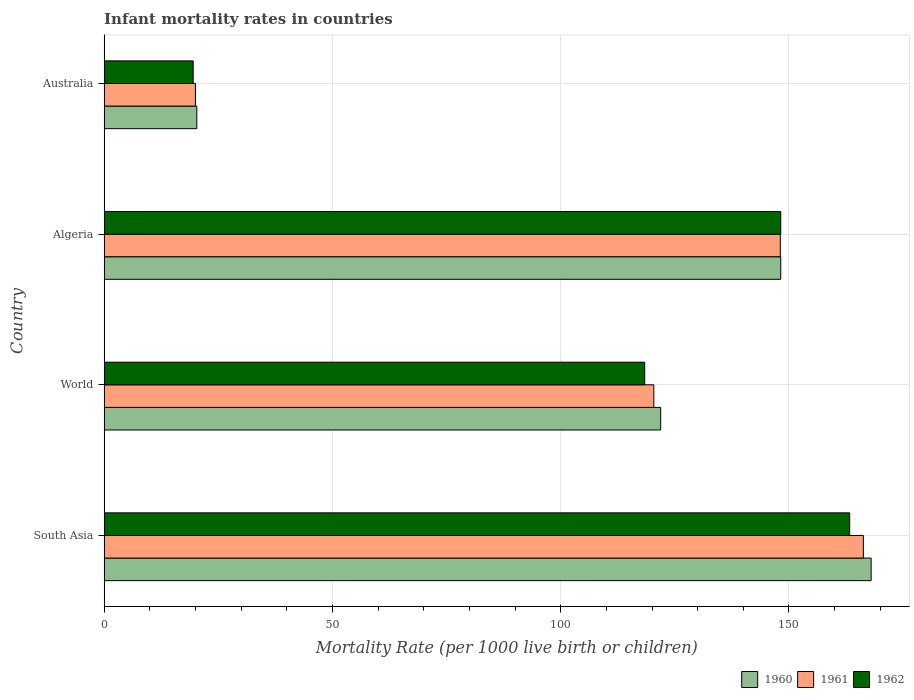How many groups of bars are there?
Your answer should be very brief. 4. Are the number of bars per tick equal to the number of legend labels?
Provide a short and direct response. Yes. How many bars are there on the 3rd tick from the bottom?
Make the answer very short. 3. What is the label of the 3rd group of bars from the top?
Give a very brief answer. World. In how many cases, is the number of bars for a given country not equal to the number of legend labels?
Give a very brief answer. 0. What is the infant mortality rate in 1961 in South Asia?
Your answer should be compact. 166.3. Across all countries, what is the maximum infant mortality rate in 1961?
Provide a short and direct response. 166.3. Across all countries, what is the minimum infant mortality rate in 1960?
Your response must be concise. 20.3. What is the total infant mortality rate in 1962 in the graph?
Your answer should be compact. 449.4. What is the difference between the infant mortality rate in 1961 in Algeria and that in Australia?
Provide a short and direct response. 128.1. What is the difference between the infant mortality rate in 1962 in South Asia and the infant mortality rate in 1960 in World?
Offer a terse response. 41.4. What is the average infant mortality rate in 1962 per country?
Give a very brief answer. 112.35. What is the difference between the infant mortality rate in 1961 and infant mortality rate in 1962 in South Asia?
Provide a short and direct response. 3. In how many countries, is the infant mortality rate in 1962 greater than 30 ?
Provide a succinct answer. 3. What is the ratio of the infant mortality rate in 1961 in Algeria to that in Australia?
Offer a very short reply. 7.4. Is the infant mortality rate in 1962 in Australia less than that in South Asia?
Ensure brevity in your answer.  Yes. What is the difference between the highest and the second highest infant mortality rate in 1962?
Keep it short and to the point. 15.1. What is the difference between the highest and the lowest infant mortality rate in 1961?
Offer a very short reply. 146.3. In how many countries, is the infant mortality rate in 1960 greater than the average infant mortality rate in 1960 taken over all countries?
Offer a terse response. 3. Is the sum of the infant mortality rate in 1962 in Algeria and World greater than the maximum infant mortality rate in 1961 across all countries?
Make the answer very short. Yes. What does the 1st bar from the top in Australia represents?
Offer a terse response. 1962. What does the 2nd bar from the bottom in Australia represents?
Your response must be concise. 1961. Is it the case that in every country, the sum of the infant mortality rate in 1962 and infant mortality rate in 1961 is greater than the infant mortality rate in 1960?
Offer a terse response. Yes. How many bars are there?
Make the answer very short. 12. What is the difference between two consecutive major ticks on the X-axis?
Ensure brevity in your answer.  50. Does the graph contain grids?
Your answer should be compact. Yes. How many legend labels are there?
Your response must be concise. 3. What is the title of the graph?
Keep it short and to the point. Infant mortality rates in countries. What is the label or title of the X-axis?
Your response must be concise. Mortality Rate (per 1000 live birth or children). What is the label or title of the Y-axis?
Your response must be concise. Country. What is the Mortality Rate (per 1000 live birth or children) in 1960 in South Asia?
Give a very brief answer. 168. What is the Mortality Rate (per 1000 live birth or children) of 1961 in South Asia?
Keep it short and to the point. 166.3. What is the Mortality Rate (per 1000 live birth or children) of 1962 in South Asia?
Give a very brief answer. 163.3. What is the Mortality Rate (per 1000 live birth or children) in 1960 in World?
Keep it short and to the point. 121.9. What is the Mortality Rate (per 1000 live birth or children) of 1961 in World?
Provide a short and direct response. 120.4. What is the Mortality Rate (per 1000 live birth or children) of 1962 in World?
Offer a very short reply. 118.4. What is the Mortality Rate (per 1000 live birth or children) of 1960 in Algeria?
Make the answer very short. 148.2. What is the Mortality Rate (per 1000 live birth or children) in 1961 in Algeria?
Your answer should be compact. 148.1. What is the Mortality Rate (per 1000 live birth or children) of 1962 in Algeria?
Offer a very short reply. 148.2. What is the Mortality Rate (per 1000 live birth or children) of 1960 in Australia?
Make the answer very short. 20.3. What is the Mortality Rate (per 1000 live birth or children) in 1961 in Australia?
Keep it short and to the point. 20. What is the Mortality Rate (per 1000 live birth or children) of 1962 in Australia?
Your response must be concise. 19.5. Across all countries, what is the maximum Mortality Rate (per 1000 live birth or children) in 1960?
Your answer should be compact. 168. Across all countries, what is the maximum Mortality Rate (per 1000 live birth or children) of 1961?
Give a very brief answer. 166.3. Across all countries, what is the maximum Mortality Rate (per 1000 live birth or children) in 1962?
Your answer should be very brief. 163.3. Across all countries, what is the minimum Mortality Rate (per 1000 live birth or children) of 1960?
Provide a short and direct response. 20.3. What is the total Mortality Rate (per 1000 live birth or children) of 1960 in the graph?
Give a very brief answer. 458.4. What is the total Mortality Rate (per 1000 live birth or children) in 1961 in the graph?
Provide a short and direct response. 454.8. What is the total Mortality Rate (per 1000 live birth or children) of 1962 in the graph?
Your answer should be very brief. 449.4. What is the difference between the Mortality Rate (per 1000 live birth or children) in 1960 in South Asia and that in World?
Your answer should be very brief. 46.1. What is the difference between the Mortality Rate (per 1000 live birth or children) in 1961 in South Asia and that in World?
Offer a very short reply. 45.9. What is the difference between the Mortality Rate (per 1000 live birth or children) of 1962 in South Asia and that in World?
Give a very brief answer. 44.9. What is the difference between the Mortality Rate (per 1000 live birth or children) of 1960 in South Asia and that in Algeria?
Your answer should be very brief. 19.8. What is the difference between the Mortality Rate (per 1000 live birth or children) in 1962 in South Asia and that in Algeria?
Offer a very short reply. 15.1. What is the difference between the Mortality Rate (per 1000 live birth or children) in 1960 in South Asia and that in Australia?
Make the answer very short. 147.7. What is the difference between the Mortality Rate (per 1000 live birth or children) of 1961 in South Asia and that in Australia?
Keep it short and to the point. 146.3. What is the difference between the Mortality Rate (per 1000 live birth or children) in 1962 in South Asia and that in Australia?
Offer a terse response. 143.8. What is the difference between the Mortality Rate (per 1000 live birth or children) in 1960 in World and that in Algeria?
Your answer should be compact. -26.3. What is the difference between the Mortality Rate (per 1000 live birth or children) in 1961 in World and that in Algeria?
Ensure brevity in your answer.  -27.7. What is the difference between the Mortality Rate (per 1000 live birth or children) of 1962 in World and that in Algeria?
Offer a very short reply. -29.8. What is the difference between the Mortality Rate (per 1000 live birth or children) in 1960 in World and that in Australia?
Offer a terse response. 101.6. What is the difference between the Mortality Rate (per 1000 live birth or children) of 1961 in World and that in Australia?
Ensure brevity in your answer.  100.4. What is the difference between the Mortality Rate (per 1000 live birth or children) of 1962 in World and that in Australia?
Your answer should be compact. 98.9. What is the difference between the Mortality Rate (per 1000 live birth or children) in 1960 in Algeria and that in Australia?
Provide a succinct answer. 127.9. What is the difference between the Mortality Rate (per 1000 live birth or children) in 1961 in Algeria and that in Australia?
Give a very brief answer. 128.1. What is the difference between the Mortality Rate (per 1000 live birth or children) of 1962 in Algeria and that in Australia?
Your answer should be very brief. 128.7. What is the difference between the Mortality Rate (per 1000 live birth or children) in 1960 in South Asia and the Mortality Rate (per 1000 live birth or children) in 1961 in World?
Give a very brief answer. 47.6. What is the difference between the Mortality Rate (per 1000 live birth or children) in 1960 in South Asia and the Mortality Rate (per 1000 live birth or children) in 1962 in World?
Your answer should be very brief. 49.6. What is the difference between the Mortality Rate (per 1000 live birth or children) of 1961 in South Asia and the Mortality Rate (per 1000 live birth or children) of 1962 in World?
Keep it short and to the point. 47.9. What is the difference between the Mortality Rate (per 1000 live birth or children) in 1960 in South Asia and the Mortality Rate (per 1000 live birth or children) in 1962 in Algeria?
Your answer should be very brief. 19.8. What is the difference between the Mortality Rate (per 1000 live birth or children) in 1961 in South Asia and the Mortality Rate (per 1000 live birth or children) in 1962 in Algeria?
Provide a short and direct response. 18.1. What is the difference between the Mortality Rate (per 1000 live birth or children) in 1960 in South Asia and the Mortality Rate (per 1000 live birth or children) in 1961 in Australia?
Make the answer very short. 148. What is the difference between the Mortality Rate (per 1000 live birth or children) in 1960 in South Asia and the Mortality Rate (per 1000 live birth or children) in 1962 in Australia?
Your response must be concise. 148.5. What is the difference between the Mortality Rate (per 1000 live birth or children) of 1961 in South Asia and the Mortality Rate (per 1000 live birth or children) of 1962 in Australia?
Your answer should be compact. 146.8. What is the difference between the Mortality Rate (per 1000 live birth or children) of 1960 in World and the Mortality Rate (per 1000 live birth or children) of 1961 in Algeria?
Provide a short and direct response. -26.2. What is the difference between the Mortality Rate (per 1000 live birth or children) of 1960 in World and the Mortality Rate (per 1000 live birth or children) of 1962 in Algeria?
Give a very brief answer. -26.3. What is the difference between the Mortality Rate (per 1000 live birth or children) in 1961 in World and the Mortality Rate (per 1000 live birth or children) in 1962 in Algeria?
Provide a succinct answer. -27.8. What is the difference between the Mortality Rate (per 1000 live birth or children) of 1960 in World and the Mortality Rate (per 1000 live birth or children) of 1961 in Australia?
Your response must be concise. 101.9. What is the difference between the Mortality Rate (per 1000 live birth or children) in 1960 in World and the Mortality Rate (per 1000 live birth or children) in 1962 in Australia?
Give a very brief answer. 102.4. What is the difference between the Mortality Rate (per 1000 live birth or children) in 1961 in World and the Mortality Rate (per 1000 live birth or children) in 1962 in Australia?
Your answer should be compact. 100.9. What is the difference between the Mortality Rate (per 1000 live birth or children) of 1960 in Algeria and the Mortality Rate (per 1000 live birth or children) of 1961 in Australia?
Your answer should be very brief. 128.2. What is the difference between the Mortality Rate (per 1000 live birth or children) of 1960 in Algeria and the Mortality Rate (per 1000 live birth or children) of 1962 in Australia?
Your answer should be compact. 128.7. What is the difference between the Mortality Rate (per 1000 live birth or children) in 1961 in Algeria and the Mortality Rate (per 1000 live birth or children) in 1962 in Australia?
Make the answer very short. 128.6. What is the average Mortality Rate (per 1000 live birth or children) of 1960 per country?
Offer a very short reply. 114.6. What is the average Mortality Rate (per 1000 live birth or children) of 1961 per country?
Provide a short and direct response. 113.7. What is the average Mortality Rate (per 1000 live birth or children) in 1962 per country?
Provide a short and direct response. 112.35. What is the difference between the Mortality Rate (per 1000 live birth or children) in 1961 and Mortality Rate (per 1000 live birth or children) in 1962 in South Asia?
Give a very brief answer. 3. What is the difference between the Mortality Rate (per 1000 live birth or children) of 1961 and Mortality Rate (per 1000 live birth or children) of 1962 in World?
Your answer should be compact. 2. What is the difference between the Mortality Rate (per 1000 live birth or children) of 1960 and Mortality Rate (per 1000 live birth or children) of 1961 in Algeria?
Make the answer very short. 0.1. What is the difference between the Mortality Rate (per 1000 live birth or children) in 1961 and Mortality Rate (per 1000 live birth or children) in 1962 in Australia?
Provide a short and direct response. 0.5. What is the ratio of the Mortality Rate (per 1000 live birth or children) in 1960 in South Asia to that in World?
Offer a terse response. 1.38. What is the ratio of the Mortality Rate (per 1000 live birth or children) in 1961 in South Asia to that in World?
Keep it short and to the point. 1.38. What is the ratio of the Mortality Rate (per 1000 live birth or children) in 1962 in South Asia to that in World?
Provide a succinct answer. 1.38. What is the ratio of the Mortality Rate (per 1000 live birth or children) in 1960 in South Asia to that in Algeria?
Offer a terse response. 1.13. What is the ratio of the Mortality Rate (per 1000 live birth or children) of 1961 in South Asia to that in Algeria?
Make the answer very short. 1.12. What is the ratio of the Mortality Rate (per 1000 live birth or children) in 1962 in South Asia to that in Algeria?
Keep it short and to the point. 1.1. What is the ratio of the Mortality Rate (per 1000 live birth or children) of 1960 in South Asia to that in Australia?
Your answer should be compact. 8.28. What is the ratio of the Mortality Rate (per 1000 live birth or children) in 1961 in South Asia to that in Australia?
Make the answer very short. 8.31. What is the ratio of the Mortality Rate (per 1000 live birth or children) of 1962 in South Asia to that in Australia?
Ensure brevity in your answer.  8.37. What is the ratio of the Mortality Rate (per 1000 live birth or children) in 1960 in World to that in Algeria?
Keep it short and to the point. 0.82. What is the ratio of the Mortality Rate (per 1000 live birth or children) of 1961 in World to that in Algeria?
Make the answer very short. 0.81. What is the ratio of the Mortality Rate (per 1000 live birth or children) of 1962 in World to that in Algeria?
Offer a terse response. 0.8. What is the ratio of the Mortality Rate (per 1000 live birth or children) in 1960 in World to that in Australia?
Provide a short and direct response. 6. What is the ratio of the Mortality Rate (per 1000 live birth or children) in 1961 in World to that in Australia?
Provide a short and direct response. 6.02. What is the ratio of the Mortality Rate (per 1000 live birth or children) in 1962 in World to that in Australia?
Provide a short and direct response. 6.07. What is the ratio of the Mortality Rate (per 1000 live birth or children) in 1960 in Algeria to that in Australia?
Ensure brevity in your answer.  7.3. What is the ratio of the Mortality Rate (per 1000 live birth or children) in 1961 in Algeria to that in Australia?
Offer a very short reply. 7.41. What is the difference between the highest and the second highest Mortality Rate (per 1000 live birth or children) in 1960?
Keep it short and to the point. 19.8. What is the difference between the highest and the second highest Mortality Rate (per 1000 live birth or children) of 1961?
Your answer should be compact. 18.2. What is the difference between the highest and the second highest Mortality Rate (per 1000 live birth or children) of 1962?
Provide a succinct answer. 15.1. What is the difference between the highest and the lowest Mortality Rate (per 1000 live birth or children) of 1960?
Offer a very short reply. 147.7. What is the difference between the highest and the lowest Mortality Rate (per 1000 live birth or children) of 1961?
Make the answer very short. 146.3. What is the difference between the highest and the lowest Mortality Rate (per 1000 live birth or children) of 1962?
Offer a terse response. 143.8. 